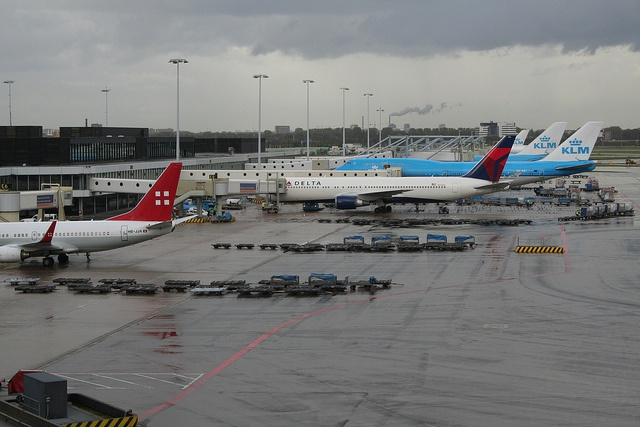Describe the objects in this image and their specific colors. I can see airplane in darkgray, lightgray, black, and gray tones, airplane in darkgray, gray, black, and maroon tones, airplane in darkgray, teal, and lightblue tones, airplane in darkgray, gray, and teal tones, and airplane in darkgray, lightgray, and gray tones in this image. 